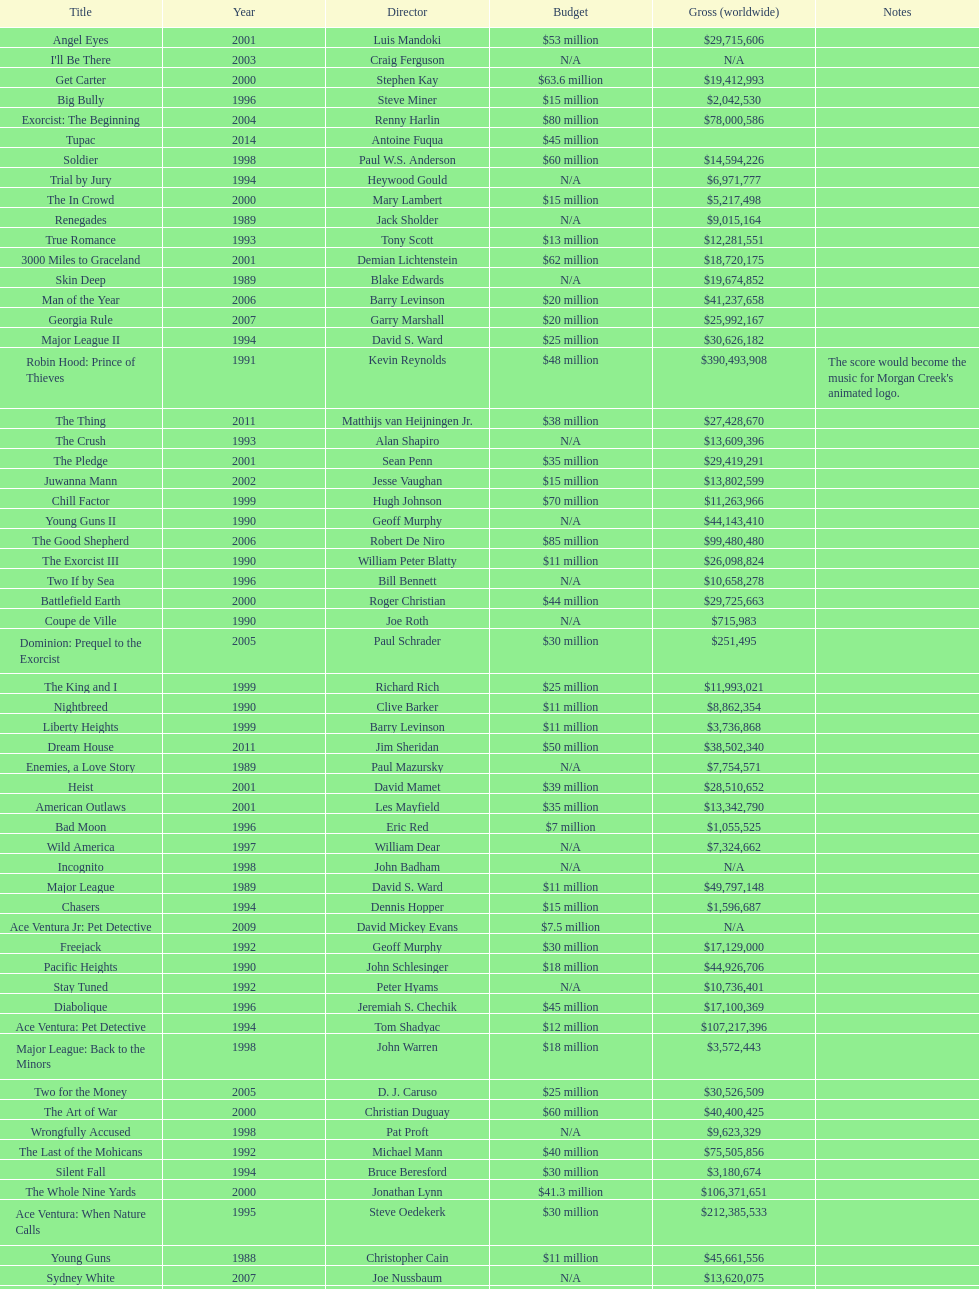Which film had a higher budget, ace ventura: when nature calls, or major league: back to the minors? Ace Ventura: When Nature Calls. 